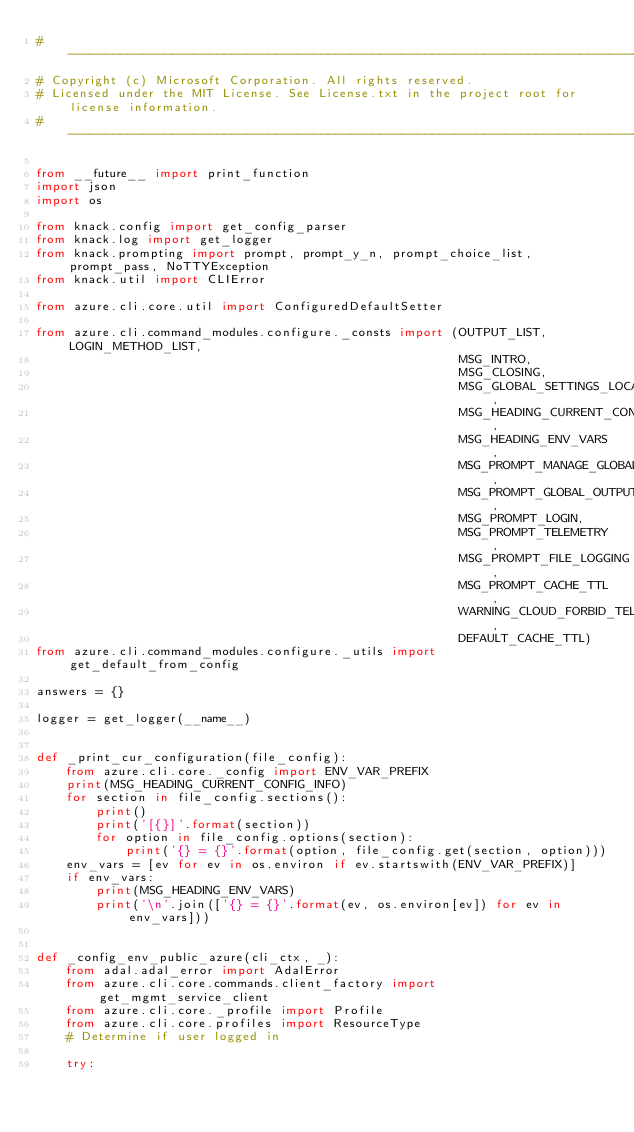<code> <loc_0><loc_0><loc_500><loc_500><_Python_># --------------------------------------------------------------------------------------------
# Copyright (c) Microsoft Corporation. All rights reserved.
# Licensed under the MIT License. See License.txt in the project root for license information.
# --------------------------------------------------------------------------------------------

from __future__ import print_function
import json
import os

from knack.config import get_config_parser
from knack.log import get_logger
from knack.prompting import prompt, prompt_y_n, prompt_choice_list, prompt_pass, NoTTYException
from knack.util import CLIError

from azure.cli.core.util import ConfiguredDefaultSetter

from azure.cli.command_modules.configure._consts import (OUTPUT_LIST, LOGIN_METHOD_LIST,
                                                         MSG_INTRO,
                                                         MSG_CLOSING,
                                                         MSG_GLOBAL_SETTINGS_LOCATION,
                                                         MSG_HEADING_CURRENT_CONFIG_INFO,
                                                         MSG_HEADING_ENV_VARS,
                                                         MSG_PROMPT_MANAGE_GLOBAL,
                                                         MSG_PROMPT_GLOBAL_OUTPUT,
                                                         MSG_PROMPT_LOGIN,
                                                         MSG_PROMPT_TELEMETRY,
                                                         MSG_PROMPT_FILE_LOGGING,
                                                         MSG_PROMPT_CACHE_TTL,
                                                         WARNING_CLOUD_FORBID_TELEMETRY,
                                                         DEFAULT_CACHE_TTL)
from azure.cli.command_modules.configure._utils import get_default_from_config

answers = {}

logger = get_logger(__name__)


def _print_cur_configuration(file_config):
    from azure.cli.core._config import ENV_VAR_PREFIX
    print(MSG_HEADING_CURRENT_CONFIG_INFO)
    for section in file_config.sections():
        print()
        print('[{}]'.format(section))
        for option in file_config.options(section):
            print('{} = {}'.format(option, file_config.get(section, option)))
    env_vars = [ev for ev in os.environ if ev.startswith(ENV_VAR_PREFIX)]
    if env_vars:
        print(MSG_HEADING_ENV_VARS)
        print('\n'.join(['{} = {}'.format(ev, os.environ[ev]) for ev in env_vars]))


def _config_env_public_azure(cli_ctx, _):
    from adal.adal_error import AdalError
    from azure.cli.core.commands.client_factory import get_mgmt_service_client
    from azure.cli.core._profile import Profile
    from azure.cli.core.profiles import ResourceType
    # Determine if user logged in

    try:</code> 